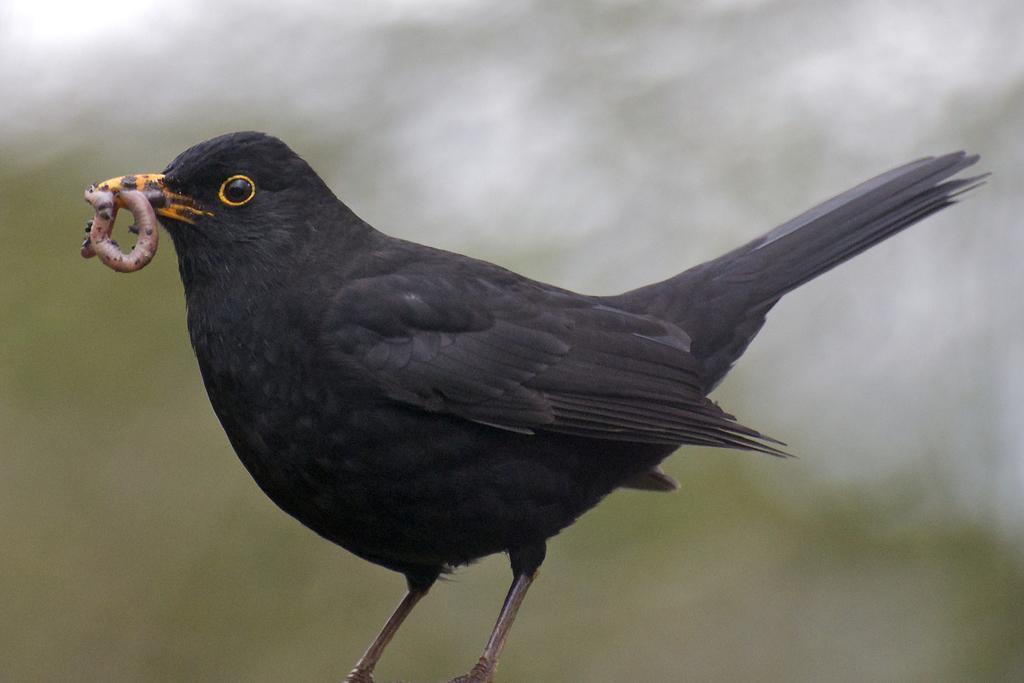Describe this image in one or two sentences. In this picture we can see a bird holding an insect with its mouth, we can see a blurry background. 